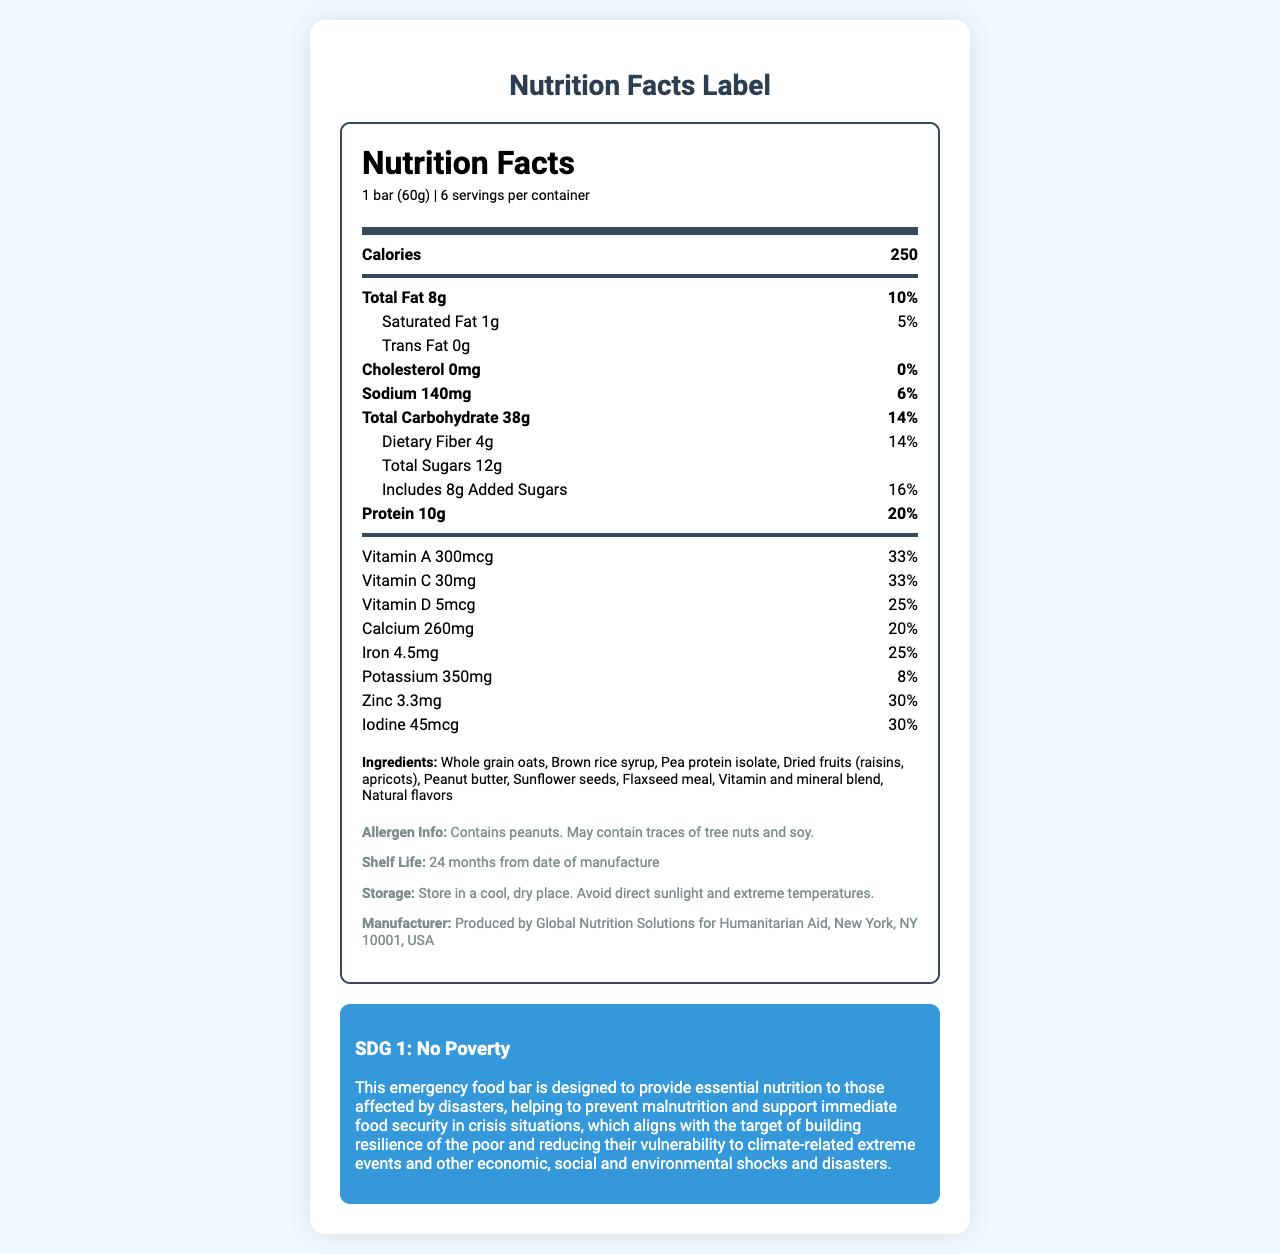what is the serving size of the NutriSave Emergency Relief Bar? The serving size is mentioned in the nutrition facts section as "1 bar (60g)".
Answer: 1 bar (60g) how many calories are in one serving of the NutriSave Emergency Relief Bar? The document states that there are 250 calories per serving.
Answer: 250 what is the total fat content per serving, and what percentage of the daily value does it represent? The total fat content is given as 8g per serving, which represents 10% of the daily value.
Answer: 8g, 10% which vitamins have the highest percent daily value per serving? Both Vitamin A and Vitamin C have the highest percent daily value per serving at 33%.
Answer: Vitamin A and Vitamin C what is the shelf life of the NutriSave Emergency Relief Bar? The shelf life is specified as 24 months from the date of manufacture.
Answer: 24 months from date of manufacture how much protein does one NutriSave Emergency Relief Bar contain? The document states that one bar contains 10g of protein.
Answer: 10g how many servings are there per container? A. 4 B. 5 C. 6 D. 7 According to the document, there are 6 servings per container.
Answer: C. 6 what is the added sugar content, and what percentage of the daily value does it represent? A. 8g, 10% B. 10g, 12% C. 8g, 16% D. 12g, 14% The document states that the added sugar content is 8g, representing 16% of the daily value.
Answer: C. 8g, 16% is there any cholesterol in the NutriSave Emergency Relief Bar? The nutrition facts state that the bar contains 0mg of cholesterol, which is 0% of the daily value.
Answer: No does the NutriSave Emergency Relief Bar contain peanuts or any potential allergens? The allergen information indicates that the bar contains peanuts and may contain traces of tree nuts and soy.
Answer: Yes what is the main idea of the document? The document outlines the nutritional composition and benefits of the NutriSave Emergency Relief Bar, emphasizing its role in providing essential nutrition during disaster relief efforts and its contribution towards reducing poverty and malnutrition.
Answer: The document provides detailed nutritional information about the NutriSave Emergency Relief Bar, including serving size, calories, macronutrient and micronutrient content, ingredients, allergen information, shelf life, storage instructions, and its alignment with SDG 1: No Poverty. which ingredient is not listed in the NutriSave Emergency Relief Bar? A. Whole grain oats B. Dried fruits (raisins, apricots) C. Soy protein isolate D. Sunflower seeds Soy protein isolate is not listed as an ingredient. The ingredients include whole grain oats, dried fruits, sunflower seeds, and more.
Answer: C. Soy protein isolate what is the storage instruction for the NutriSave Emergency Relief Bar? The document advises storing the bar in a cool, dry place and avoiding direct sunlight and extreme temperatures.
Answer: Store in a cool, dry place. Avoid direct sunlight and extreme temperatures. how much sodium does one serving of the NutriSave Emergency Relief Bar contain? The nutrition facts specify that one serving contains 140mg of sodium.
Answer: 140mg what is the manufactured location of the NutriSave Emergency Relief Bar? The manufacturer is stated as Global Nutrition Solutions for Humanitarian Aid, located in New York, NY 10001, USA.
Answer: New York, NY 10001, USA how is the NutriSave Emergency Relief Bar aligned with SDG 1: No Poverty? The SDG information section explains that the bar supports SDG 1 by providing essential nutrition during emergencies, aligning with the target of reducing vulnerability and building resilience against various shocks.
Answer: The bar is designed to provide essential nutrition during disasters, helping to prevent malnutrition and supporting immediate food security, thus building the resilience of the poor and reducing their vulnerability to various shocks. what is the total carbohydrate content in one NutriSave Emergency Relief Bar? The document states that each bar contains 38g of total carbohydrates.
Answer: 38g what is the amount of vitamin D in one NutriSave Emergency Relief Bar? The document mentions that one bar contains 5mcg of vitamin D.
Answer: 5mcg what are the specific health benefits of the NutriSave Emergency Relief Bar mentioned in the document? The document provides nutritional information and the role of the bar in preventing malnutrition, but does not detail specific health benefits beyond general nutritional data and disaster relief support.
Answer: Not enough information are there any added flavors in the NutriSave Emergency Relief Bar? The ingredients list mentions "Natural flavors" as one of the components.
Answer: Yes, natural flavors 